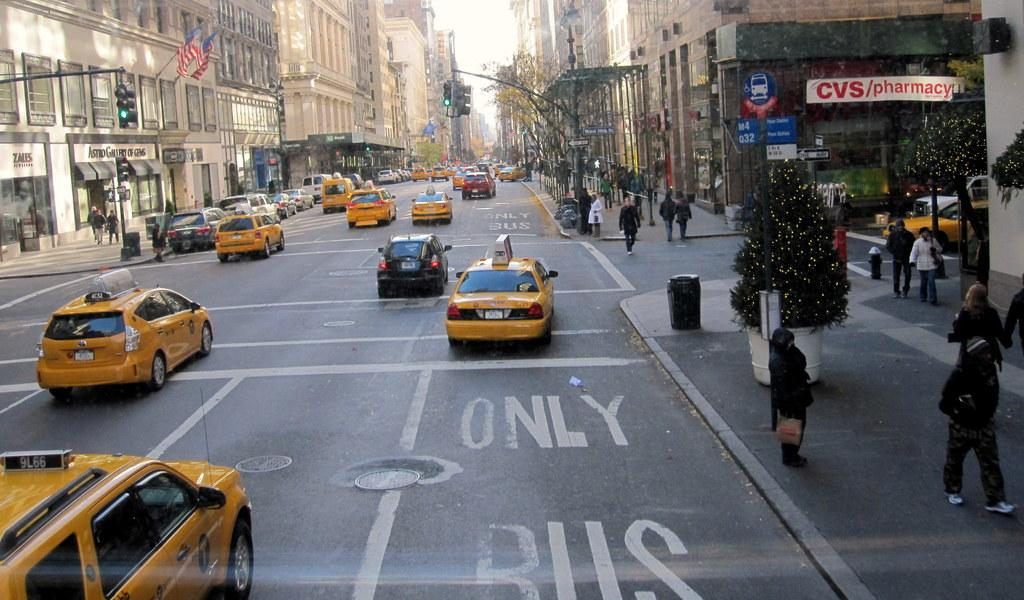<image>
Relay a brief, clear account of the picture shown. Taxis drive down the road in a Bus Only Lane. 